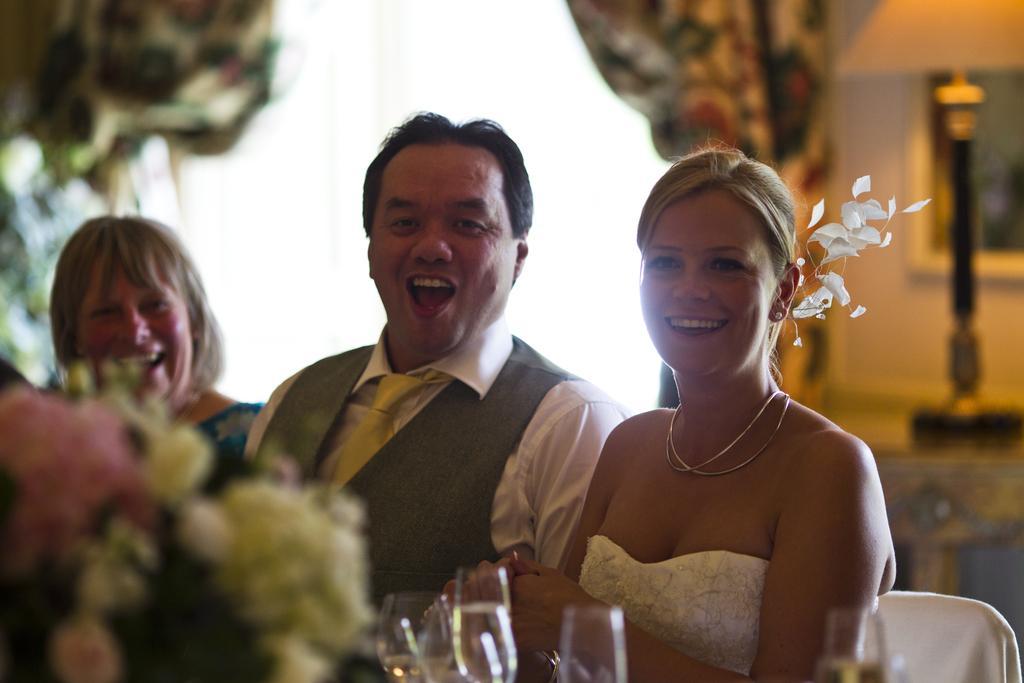Can you describe this image briefly? In this picture we can see three persons holding a beautiful smile on their faces. In Front of them we can see glasses. At the left side of the picture we can see flowers. At the backgrounds of the picture we can see a wall. 